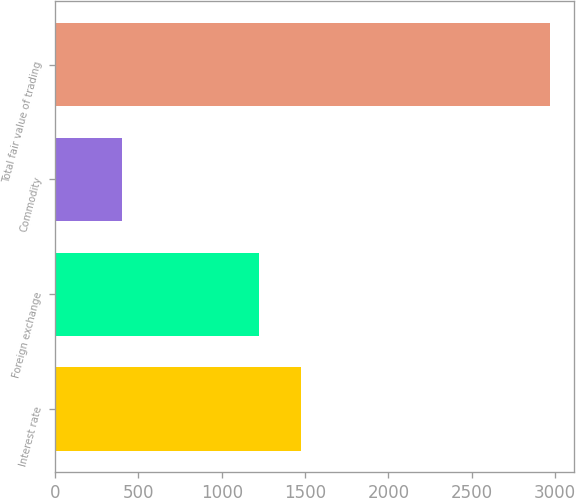<chart> <loc_0><loc_0><loc_500><loc_500><bar_chart><fcel>Interest rate<fcel>Foreign exchange<fcel>Commodity<fcel>Total fair value of trading<nl><fcel>1477.5<fcel>1221<fcel>403<fcel>2968<nl></chart> 